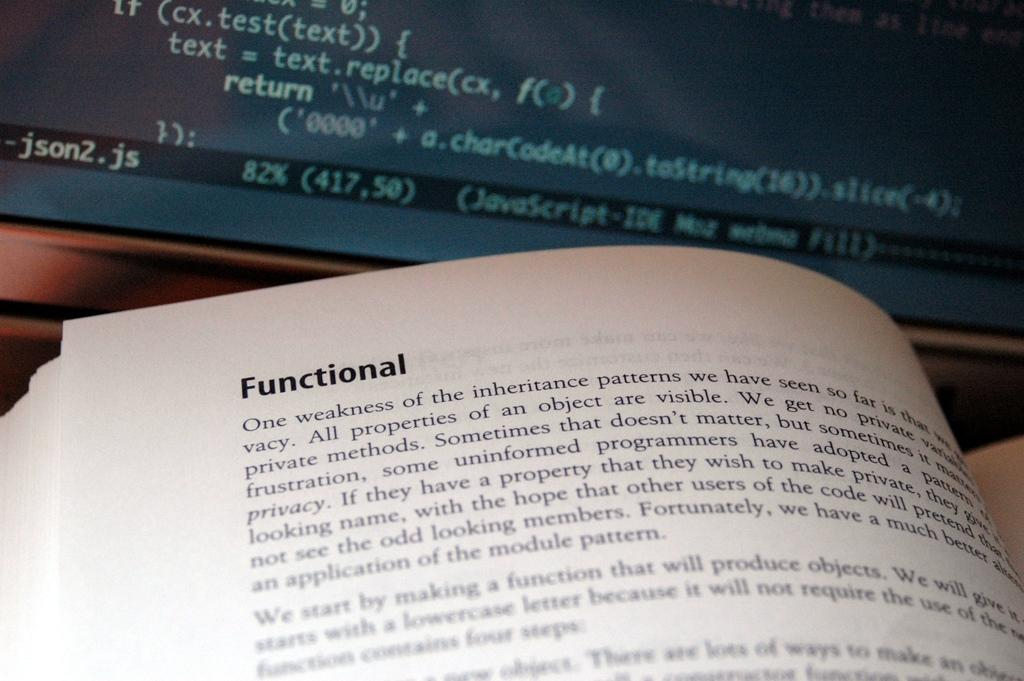<image>
Give a short and clear explanation of the subsequent image. An opened book near a computer monitor features the heading Functional on its page. 